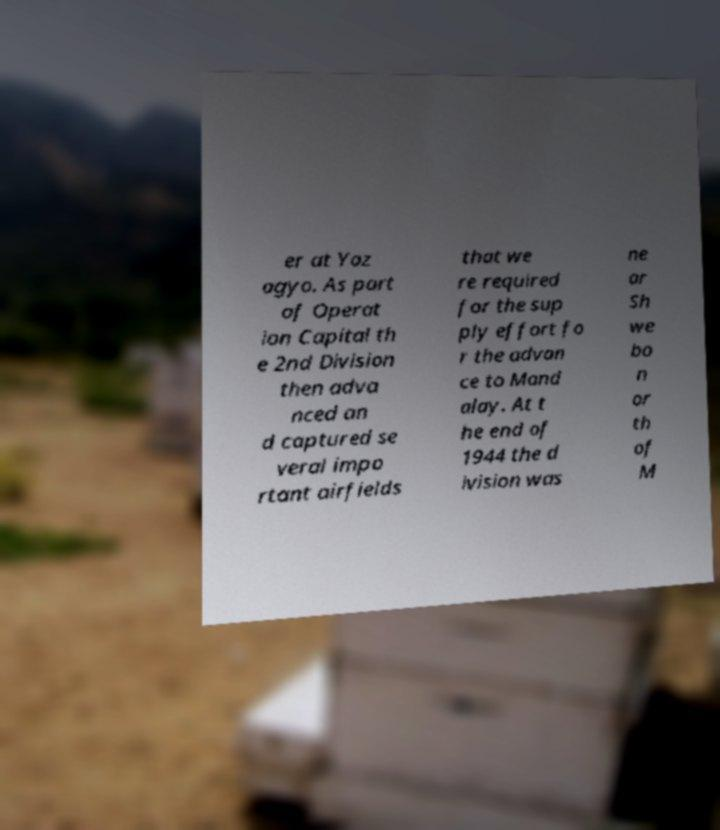I need the written content from this picture converted into text. Can you do that? er at Yaz agyo. As part of Operat ion Capital th e 2nd Division then adva nced an d captured se veral impo rtant airfields that we re required for the sup ply effort fo r the advan ce to Mand alay. At t he end of 1944 the d ivision was ne ar Sh we bo n or th of M 